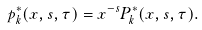<formula> <loc_0><loc_0><loc_500><loc_500>p _ { k } ^ { * } ( x , s , \tau ) = x ^ { - s } P _ { k } ^ { * } ( x , s , \tau ) .</formula> 